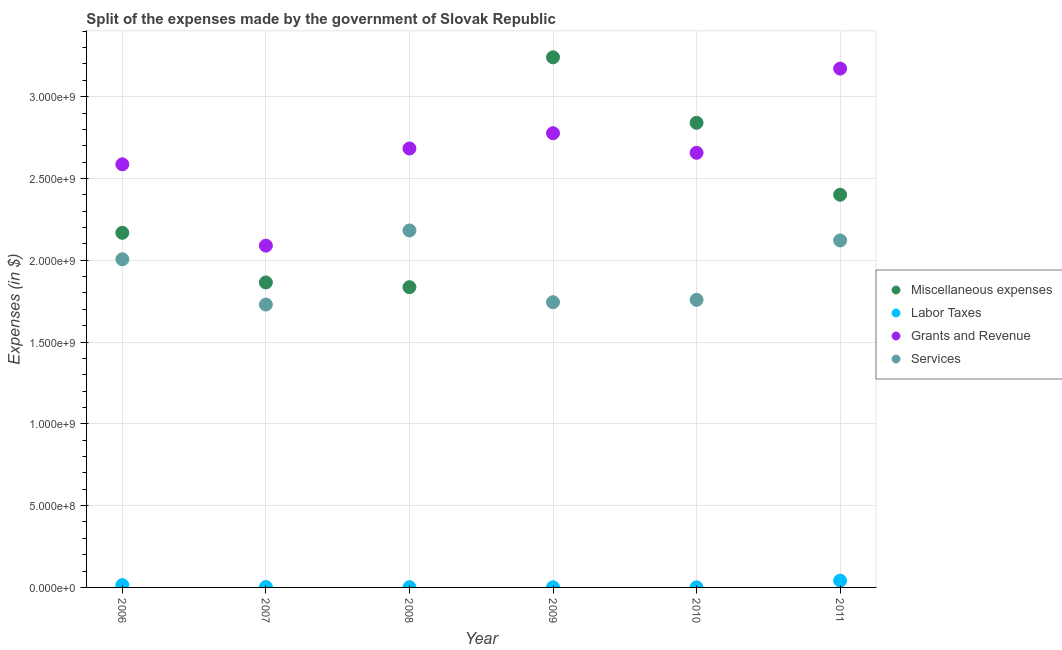Is the number of dotlines equal to the number of legend labels?
Your answer should be compact. Yes. What is the amount spent on labor taxes in 2007?
Keep it short and to the point. 2.58e+06. Across all years, what is the maximum amount spent on services?
Ensure brevity in your answer.  2.18e+09. Across all years, what is the minimum amount spent on grants and revenue?
Your response must be concise. 2.09e+09. What is the total amount spent on services in the graph?
Your answer should be very brief. 1.15e+1. What is the difference between the amount spent on grants and revenue in 2006 and that in 2007?
Your response must be concise. 4.97e+08. What is the difference between the amount spent on services in 2007 and the amount spent on labor taxes in 2008?
Offer a very short reply. 1.73e+09. What is the average amount spent on grants and revenue per year?
Your answer should be compact. 2.66e+09. In the year 2010, what is the difference between the amount spent on miscellaneous expenses and amount spent on labor taxes?
Your response must be concise. 2.84e+09. What is the ratio of the amount spent on miscellaneous expenses in 2006 to that in 2009?
Keep it short and to the point. 0.67. What is the difference between the highest and the second highest amount spent on grants and revenue?
Offer a very short reply. 3.95e+08. What is the difference between the highest and the lowest amount spent on grants and revenue?
Ensure brevity in your answer.  1.08e+09. In how many years, is the amount spent on grants and revenue greater than the average amount spent on grants and revenue taken over all years?
Your answer should be compact. 3. Is the sum of the amount spent on labor taxes in 2008 and 2009 greater than the maximum amount spent on grants and revenue across all years?
Offer a very short reply. No. Is it the case that in every year, the sum of the amount spent on labor taxes and amount spent on services is greater than the sum of amount spent on grants and revenue and amount spent on miscellaneous expenses?
Give a very brief answer. No. Does the amount spent on grants and revenue monotonically increase over the years?
Give a very brief answer. No. Is the amount spent on labor taxes strictly greater than the amount spent on grants and revenue over the years?
Make the answer very short. No. Is the amount spent on labor taxes strictly less than the amount spent on miscellaneous expenses over the years?
Your answer should be compact. Yes. What is the difference between two consecutive major ticks on the Y-axis?
Ensure brevity in your answer.  5.00e+08. Are the values on the major ticks of Y-axis written in scientific E-notation?
Provide a short and direct response. Yes. Does the graph contain any zero values?
Offer a very short reply. No. Where does the legend appear in the graph?
Ensure brevity in your answer.  Center right. How many legend labels are there?
Your answer should be compact. 4. How are the legend labels stacked?
Offer a terse response. Vertical. What is the title of the graph?
Offer a terse response. Split of the expenses made by the government of Slovak Republic. What is the label or title of the Y-axis?
Offer a terse response. Expenses (in $). What is the Expenses (in $) of Miscellaneous expenses in 2006?
Give a very brief answer. 2.17e+09. What is the Expenses (in $) in Labor Taxes in 2006?
Provide a succinct answer. 1.41e+07. What is the Expenses (in $) of Grants and Revenue in 2006?
Ensure brevity in your answer.  2.59e+09. What is the Expenses (in $) in Services in 2006?
Your response must be concise. 2.01e+09. What is the Expenses (in $) in Miscellaneous expenses in 2007?
Provide a short and direct response. 1.86e+09. What is the Expenses (in $) of Labor Taxes in 2007?
Offer a terse response. 2.58e+06. What is the Expenses (in $) of Grants and Revenue in 2007?
Your response must be concise. 2.09e+09. What is the Expenses (in $) in Services in 2007?
Keep it short and to the point. 1.73e+09. What is the Expenses (in $) of Miscellaneous expenses in 2008?
Your answer should be compact. 1.84e+09. What is the Expenses (in $) of Labor Taxes in 2008?
Offer a very short reply. 1.39e+06. What is the Expenses (in $) of Grants and Revenue in 2008?
Give a very brief answer. 2.68e+09. What is the Expenses (in $) of Services in 2008?
Provide a succinct answer. 2.18e+09. What is the Expenses (in $) of Miscellaneous expenses in 2009?
Your answer should be very brief. 3.24e+09. What is the Expenses (in $) of Labor Taxes in 2009?
Offer a very short reply. 7.25e+05. What is the Expenses (in $) of Grants and Revenue in 2009?
Offer a very short reply. 2.78e+09. What is the Expenses (in $) of Services in 2009?
Keep it short and to the point. 1.74e+09. What is the Expenses (in $) in Miscellaneous expenses in 2010?
Ensure brevity in your answer.  2.84e+09. What is the Expenses (in $) in Labor Taxes in 2010?
Your response must be concise. 3.61e+05. What is the Expenses (in $) of Grants and Revenue in 2010?
Keep it short and to the point. 2.66e+09. What is the Expenses (in $) in Services in 2010?
Offer a very short reply. 1.76e+09. What is the Expenses (in $) in Miscellaneous expenses in 2011?
Offer a very short reply. 2.40e+09. What is the Expenses (in $) of Labor Taxes in 2011?
Offer a very short reply. 4.13e+07. What is the Expenses (in $) in Grants and Revenue in 2011?
Make the answer very short. 3.17e+09. What is the Expenses (in $) of Services in 2011?
Make the answer very short. 2.12e+09. Across all years, what is the maximum Expenses (in $) in Miscellaneous expenses?
Your response must be concise. 3.24e+09. Across all years, what is the maximum Expenses (in $) of Labor Taxes?
Your answer should be very brief. 4.13e+07. Across all years, what is the maximum Expenses (in $) of Grants and Revenue?
Ensure brevity in your answer.  3.17e+09. Across all years, what is the maximum Expenses (in $) of Services?
Your answer should be compact. 2.18e+09. Across all years, what is the minimum Expenses (in $) of Miscellaneous expenses?
Give a very brief answer. 1.84e+09. Across all years, what is the minimum Expenses (in $) of Labor Taxes?
Provide a short and direct response. 3.61e+05. Across all years, what is the minimum Expenses (in $) of Grants and Revenue?
Your answer should be very brief. 2.09e+09. Across all years, what is the minimum Expenses (in $) in Services?
Provide a short and direct response. 1.73e+09. What is the total Expenses (in $) of Miscellaneous expenses in the graph?
Make the answer very short. 1.43e+1. What is the total Expenses (in $) in Labor Taxes in the graph?
Your answer should be compact. 6.05e+07. What is the total Expenses (in $) of Grants and Revenue in the graph?
Keep it short and to the point. 1.60e+1. What is the total Expenses (in $) in Services in the graph?
Give a very brief answer. 1.15e+1. What is the difference between the Expenses (in $) of Miscellaneous expenses in 2006 and that in 2007?
Ensure brevity in your answer.  3.03e+08. What is the difference between the Expenses (in $) in Labor Taxes in 2006 and that in 2007?
Offer a terse response. 1.15e+07. What is the difference between the Expenses (in $) in Grants and Revenue in 2006 and that in 2007?
Ensure brevity in your answer.  4.97e+08. What is the difference between the Expenses (in $) in Services in 2006 and that in 2007?
Your answer should be very brief. 2.77e+08. What is the difference between the Expenses (in $) in Miscellaneous expenses in 2006 and that in 2008?
Provide a short and direct response. 3.32e+08. What is the difference between the Expenses (in $) in Labor Taxes in 2006 and that in 2008?
Your answer should be very brief. 1.27e+07. What is the difference between the Expenses (in $) in Grants and Revenue in 2006 and that in 2008?
Offer a terse response. -9.66e+07. What is the difference between the Expenses (in $) in Services in 2006 and that in 2008?
Make the answer very short. -1.76e+08. What is the difference between the Expenses (in $) of Miscellaneous expenses in 2006 and that in 2009?
Your answer should be compact. -1.07e+09. What is the difference between the Expenses (in $) in Labor Taxes in 2006 and that in 2009?
Provide a succinct answer. 1.34e+07. What is the difference between the Expenses (in $) of Grants and Revenue in 2006 and that in 2009?
Keep it short and to the point. -1.90e+08. What is the difference between the Expenses (in $) of Services in 2006 and that in 2009?
Your answer should be very brief. 2.63e+08. What is the difference between the Expenses (in $) of Miscellaneous expenses in 2006 and that in 2010?
Offer a terse response. -6.73e+08. What is the difference between the Expenses (in $) of Labor Taxes in 2006 and that in 2010?
Keep it short and to the point. 1.37e+07. What is the difference between the Expenses (in $) of Grants and Revenue in 2006 and that in 2010?
Keep it short and to the point. -7.03e+07. What is the difference between the Expenses (in $) of Services in 2006 and that in 2010?
Give a very brief answer. 2.48e+08. What is the difference between the Expenses (in $) in Miscellaneous expenses in 2006 and that in 2011?
Make the answer very short. -2.33e+08. What is the difference between the Expenses (in $) of Labor Taxes in 2006 and that in 2011?
Give a very brief answer. -2.72e+07. What is the difference between the Expenses (in $) in Grants and Revenue in 2006 and that in 2011?
Your answer should be very brief. -5.85e+08. What is the difference between the Expenses (in $) of Services in 2006 and that in 2011?
Offer a terse response. -1.15e+08. What is the difference between the Expenses (in $) in Miscellaneous expenses in 2007 and that in 2008?
Ensure brevity in your answer.  2.90e+07. What is the difference between the Expenses (in $) in Labor Taxes in 2007 and that in 2008?
Offer a very short reply. 1.19e+06. What is the difference between the Expenses (in $) of Grants and Revenue in 2007 and that in 2008?
Offer a terse response. -5.94e+08. What is the difference between the Expenses (in $) in Services in 2007 and that in 2008?
Keep it short and to the point. -4.53e+08. What is the difference between the Expenses (in $) of Miscellaneous expenses in 2007 and that in 2009?
Your response must be concise. -1.38e+09. What is the difference between the Expenses (in $) in Labor Taxes in 2007 and that in 2009?
Give a very brief answer. 1.86e+06. What is the difference between the Expenses (in $) of Grants and Revenue in 2007 and that in 2009?
Offer a terse response. -6.87e+08. What is the difference between the Expenses (in $) of Services in 2007 and that in 2009?
Provide a short and direct response. -1.42e+07. What is the difference between the Expenses (in $) of Miscellaneous expenses in 2007 and that in 2010?
Give a very brief answer. -9.76e+08. What is the difference between the Expenses (in $) of Labor Taxes in 2007 and that in 2010?
Provide a short and direct response. 2.22e+06. What is the difference between the Expenses (in $) of Grants and Revenue in 2007 and that in 2010?
Offer a very short reply. -5.68e+08. What is the difference between the Expenses (in $) in Services in 2007 and that in 2010?
Provide a short and direct response. -2.88e+07. What is the difference between the Expenses (in $) of Miscellaneous expenses in 2007 and that in 2011?
Ensure brevity in your answer.  -5.36e+08. What is the difference between the Expenses (in $) in Labor Taxes in 2007 and that in 2011?
Provide a short and direct response. -3.87e+07. What is the difference between the Expenses (in $) of Grants and Revenue in 2007 and that in 2011?
Provide a succinct answer. -1.08e+09. What is the difference between the Expenses (in $) in Services in 2007 and that in 2011?
Your response must be concise. -3.92e+08. What is the difference between the Expenses (in $) in Miscellaneous expenses in 2008 and that in 2009?
Your answer should be compact. -1.41e+09. What is the difference between the Expenses (in $) in Labor Taxes in 2008 and that in 2009?
Ensure brevity in your answer.  6.67e+05. What is the difference between the Expenses (in $) in Grants and Revenue in 2008 and that in 2009?
Your response must be concise. -9.34e+07. What is the difference between the Expenses (in $) in Services in 2008 and that in 2009?
Provide a succinct answer. 4.39e+08. What is the difference between the Expenses (in $) in Miscellaneous expenses in 2008 and that in 2010?
Provide a short and direct response. -1.00e+09. What is the difference between the Expenses (in $) in Labor Taxes in 2008 and that in 2010?
Provide a short and direct response. 1.03e+06. What is the difference between the Expenses (in $) in Grants and Revenue in 2008 and that in 2010?
Ensure brevity in your answer.  2.63e+07. What is the difference between the Expenses (in $) of Services in 2008 and that in 2010?
Your answer should be compact. 4.24e+08. What is the difference between the Expenses (in $) of Miscellaneous expenses in 2008 and that in 2011?
Your response must be concise. -5.65e+08. What is the difference between the Expenses (in $) in Labor Taxes in 2008 and that in 2011?
Your answer should be compact. -3.99e+07. What is the difference between the Expenses (in $) of Grants and Revenue in 2008 and that in 2011?
Make the answer very short. -4.88e+08. What is the difference between the Expenses (in $) of Services in 2008 and that in 2011?
Ensure brevity in your answer.  6.11e+07. What is the difference between the Expenses (in $) of Miscellaneous expenses in 2009 and that in 2010?
Give a very brief answer. 4.00e+08. What is the difference between the Expenses (in $) of Labor Taxes in 2009 and that in 2010?
Your answer should be very brief. 3.64e+05. What is the difference between the Expenses (in $) of Grants and Revenue in 2009 and that in 2010?
Ensure brevity in your answer.  1.20e+08. What is the difference between the Expenses (in $) of Services in 2009 and that in 2010?
Provide a short and direct response. -1.45e+07. What is the difference between the Expenses (in $) of Miscellaneous expenses in 2009 and that in 2011?
Your response must be concise. 8.40e+08. What is the difference between the Expenses (in $) of Labor Taxes in 2009 and that in 2011?
Keep it short and to the point. -4.06e+07. What is the difference between the Expenses (in $) in Grants and Revenue in 2009 and that in 2011?
Offer a terse response. -3.95e+08. What is the difference between the Expenses (in $) in Services in 2009 and that in 2011?
Keep it short and to the point. -3.78e+08. What is the difference between the Expenses (in $) in Miscellaneous expenses in 2010 and that in 2011?
Make the answer very short. 4.40e+08. What is the difference between the Expenses (in $) in Labor Taxes in 2010 and that in 2011?
Provide a succinct answer. -4.10e+07. What is the difference between the Expenses (in $) in Grants and Revenue in 2010 and that in 2011?
Make the answer very short. -5.15e+08. What is the difference between the Expenses (in $) in Services in 2010 and that in 2011?
Offer a terse response. -3.63e+08. What is the difference between the Expenses (in $) in Miscellaneous expenses in 2006 and the Expenses (in $) in Labor Taxes in 2007?
Keep it short and to the point. 2.17e+09. What is the difference between the Expenses (in $) in Miscellaneous expenses in 2006 and the Expenses (in $) in Grants and Revenue in 2007?
Give a very brief answer. 7.84e+07. What is the difference between the Expenses (in $) of Miscellaneous expenses in 2006 and the Expenses (in $) of Services in 2007?
Provide a succinct answer. 4.39e+08. What is the difference between the Expenses (in $) of Labor Taxes in 2006 and the Expenses (in $) of Grants and Revenue in 2007?
Your response must be concise. -2.08e+09. What is the difference between the Expenses (in $) of Labor Taxes in 2006 and the Expenses (in $) of Services in 2007?
Give a very brief answer. -1.72e+09. What is the difference between the Expenses (in $) in Grants and Revenue in 2006 and the Expenses (in $) in Services in 2007?
Make the answer very short. 8.57e+08. What is the difference between the Expenses (in $) in Miscellaneous expenses in 2006 and the Expenses (in $) in Labor Taxes in 2008?
Offer a very short reply. 2.17e+09. What is the difference between the Expenses (in $) in Miscellaneous expenses in 2006 and the Expenses (in $) in Grants and Revenue in 2008?
Offer a very short reply. -5.15e+08. What is the difference between the Expenses (in $) in Miscellaneous expenses in 2006 and the Expenses (in $) in Services in 2008?
Your answer should be very brief. -1.45e+07. What is the difference between the Expenses (in $) in Labor Taxes in 2006 and the Expenses (in $) in Grants and Revenue in 2008?
Make the answer very short. -2.67e+09. What is the difference between the Expenses (in $) in Labor Taxes in 2006 and the Expenses (in $) in Services in 2008?
Ensure brevity in your answer.  -2.17e+09. What is the difference between the Expenses (in $) of Grants and Revenue in 2006 and the Expenses (in $) of Services in 2008?
Your response must be concise. 4.04e+08. What is the difference between the Expenses (in $) of Miscellaneous expenses in 2006 and the Expenses (in $) of Labor Taxes in 2009?
Provide a short and direct response. 2.17e+09. What is the difference between the Expenses (in $) of Miscellaneous expenses in 2006 and the Expenses (in $) of Grants and Revenue in 2009?
Make the answer very short. -6.09e+08. What is the difference between the Expenses (in $) of Miscellaneous expenses in 2006 and the Expenses (in $) of Services in 2009?
Your answer should be compact. 4.24e+08. What is the difference between the Expenses (in $) in Labor Taxes in 2006 and the Expenses (in $) in Grants and Revenue in 2009?
Your answer should be very brief. -2.76e+09. What is the difference between the Expenses (in $) in Labor Taxes in 2006 and the Expenses (in $) in Services in 2009?
Give a very brief answer. -1.73e+09. What is the difference between the Expenses (in $) of Grants and Revenue in 2006 and the Expenses (in $) of Services in 2009?
Your answer should be very brief. 8.43e+08. What is the difference between the Expenses (in $) of Miscellaneous expenses in 2006 and the Expenses (in $) of Labor Taxes in 2010?
Provide a short and direct response. 2.17e+09. What is the difference between the Expenses (in $) in Miscellaneous expenses in 2006 and the Expenses (in $) in Grants and Revenue in 2010?
Make the answer very short. -4.89e+08. What is the difference between the Expenses (in $) in Miscellaneous expenses in 2006 and the Expenses (in $) in Services in 2010?
Offer a very short reply. 4.10e+08. What is the difference between the Expenses (in $) of Labor Taxes in 2006 and the Expenses (in $) of Grants and Revenue in 2010?
Offer a very short reply. -2.64e+09. What is the difference between the Expenses (in $) in Labor Taxes in 2006 and the Expenses (in $) in Services in 2010?
Your response must be concise. -1.74e+09. What is the difference between the Expenses (in $) in Grants and Revenue in 2006 and the Expenses (in $) in Services in 2010?
Offer a terse response. 8.29e+08. What is the difference between the Expenses (in $) of Miscellaneous expenses in 2006 and the Expenses (in $) of Labor Taxes in 2011?
Offer a terse response. 2.13e+09. What is the difference between the Expenses (in $) of Miscellaneous expenses in 2006 and the Expenses (in $) of Grants and Revenue in 2011?
Your response must be concise. -1.00e+09. What is the difference between the Expenses (in $) in Miscellaneous expenses in 2006 and the Expenses (in $) in Services in 2011?
Make the answer very short. 4.66e+07. What is the difference between the Expenses (in $) in Labor Taxes in 2006 and the Expenses (in $) in Grants and Revenue in 2011?
Your answer should be compact. -3.16e+09. What is the difference between the Expenses (in $) of Labor Taxes in 2006 and the Expenses (in $) of Services in 2011?
Provide a succinct answer. -2.11e+09. What is the difference between the Expenses (in $) of Grants and Revenue in 2006 and the Expenses (in $) of Services in 2011?
Your response must be concise. 4.65e+08. What is the difference between the Expenses (in $) in Miscellaneous expenses in 2007 and the Expenses (in $) in Labor Taxes in 2008?
Your response must be concise. 1.86e+09. What is the difference between the Expenses (in $) in Miscellaneous expenses in 2007 and the Expenses (in $) in Grants and Revenue in 2008?
Give a very brief answer. -8.19e+08. What is the difference between the Expenses (in $) in Miscellaneous expenses in 2007 and the Expenses (in $) in Services in 2008?
Offer a terse response. -3.18e+08. What is the difference between the Expenses (in $) of Labor Taxes in 2007 and the Expenses (in $) of Grants and Revenue in 2008?
Offer a very short reply. -2.68e+09. What is the difference between the Expenses (in $) in Labor Taxes in 2007 and the Expenses (in $) in Services in 2008?
Your answer should be very brief. -2.18e+09. What is the difference between the Expenses (in $) in Grants and Revenue in 2007 and the Expenses (in $) in Services in 2008?
Your answer should be very brief. -9.29e+07. What is the difference between the Expenses (in $) in Miscellaneous expenses in 2007 and the Expenses (in $) in Labor Taxes in 2009?
Your response must be concise. 1.86e+09. What is the difference between the Expenses (in $) of Miscellaneous expenses in 2007 and the Expenses (in $) of Grants and Revenue in 2009?
Your answer should be compact. -9.12e+08. What is the difference between the Expenses (in $) in Miscellaneous expenses in 2007 and the Expenses (in $) in Services in 2009?
Your response must be concise. 1.21e+08. What is the difference between the Expenses (in $) in Labor Taxes in 2007 and the Expenses (in $) in Grants and Revenue in 2009?
Keep it short and to the point. -2.77e+09. What is the difference between the Expenses (in $) of Labor Taxes in 2007 and the Expenses (in $) of Services in 2009?
Make the answer very short. -1.74e+09. What is the difference between the Expenses (in $) in Grants and Revenue in 2007 and the Expenses (in $) in Services in 2009?
Make the answer very short. 3.46e+08. What is the difference between the Expenses (in $) of Miscellaneous expenses in 2007 and the Expenses (in $) of Labor Taxes in 2010?
Your answer should be compact. 1.86e+09. What is the difference between the Expenses (in $) in Miscellaneous expenses in 2007 and the Expenses (in $) in Grants and Revenue in 2010?
Your response must be concise. -7.92e+08. What is the difference between the Expenses (in $) in Miscellaneous expenses in 2007 and the Expenses (in $) in Services in 2010?
Give a very brief answer. 1.06e+08. What is the difference between the Expenses (in $) in Labor Taxes in 2007 and the Expenses (in $) in Grants and Revenue in 2010?
Offer a very short reply. -2.65e+09. What is the difference between the Expenses (in $) of Labor Taxes in 2007 and the Expenses (in $) of Services in 2010?
Offer a terse response. -1.76e+09. What is the difference between the Expenses (in $) of Grants and Revenue in 2007 and the Expenses (in $) of Services in 2010?
Offer a terse response. 3.31e+08. What is the difference between the Expenses (in $) in Miscellaneous expenses in 2007 and the Expenses (in $) in Labor Taxes in 2011?
Provide a succinct answer. 1.82e+09. What is the difference between the Expenses (in $) in Miscellaneous expenses in 2007 and the Expenses (in $) in Grants and Revenue in 2011?
Your answer should be compact. -1.31e+09. What is the difference between the Expenses (in $) of Miscellaneous expenses in 2007 and the Expenses (in $) of Services in 2011?
Your answer should be very brief. -2.57e+08. What is the difference between the Expenses (in $) of Labor Taxes in 2007 and the Expenses (in $) of Grants and Revenue in 2011?
Keep it short and to the point. -3.17e+09. What is the difference between the Expenses (in $) of Labor Taxes in 2007 and the Expenses (in $) of Services in 2011?
Offer a very short reply. -2.12e+09. What is the difference between the Expenses (in $) in Grants and Revenue in 2007 and the Expenses (in $) in Services in 2011?
Ensure brevity in your answer.  -3.18e+07. What is the difference between the Expenses (in $) in Miscellaneous expenses in 2008 and the Expenses (in $) in Labor Taxes in 2009?
Your response must be concise. 1.83e+09. What is the difference between the Expenses (in $) of Miscellaneous expenses in 2008 and the Expenses (in $) of Grants and Revenue in 2009?
Ensure brevity in your answer.  -9.41e+08. What is the difference between the Expenses (in $) in Miscellaneous expenses in 2008 and the Expenses (in $) in Services in 2009?
Your response must be concise. 9.20e+07. What is the difference between the Expenses (in $) in Labor Taxes in 2008 and the Expenses (in $) in Grants and Revenue in 2009?
Offer a very short reply. -2.78e+09. What is the difference between the Expenses (in $) of Labor Taxes in 2008 and the Expenses (in $) of Services in 2009?
Provide a short and direct response. -1.74e+09. What is the difference between the Expenses (in $) of Grants and Revenue in 2008 and the Expenses (in $) of Services in 2009?
Ensure brevity in your answer.  9.40e+08. What is the difference between the Expenses (in $) of Miscellaneous expenses in 2008 and the Expenses (in $) of Labor Taxes in 2010?
Keep it short and to the point. 1.84e+09. What is the difference between the Expenses (in $) in Miscellaneous expenses in 2008 and the Expenses (in $) in Grants and Revenue in 2010?
Ensure brevity in your answer.  -8.21e+08. What is the difference between the Expenses (in $) of Miscellaneous expenses in 2008 and the Expenses (in $) of Services in 2010?
Your answer should be very brief. 7.75e+07. What is the difference between the Expenses (in $) of Labor Taxes in 2008 and the Expenses (in $) of Grants and Revenue in 2010?
Your response must be concise. -2.66e+09. What is the difference between the Expenses (in $) of Labor Taxes in 2008 and the Expenses (in $) of Services in 2010?
Provide a succinct answer. -1.76e+09. What is the difference between the Expenses (in $) of Grants and Revenue in 2008 and the Expenses (in $) of Services in 2010?
Your response must be concise. 9.25e+08. What is the difference between the Expenses (in $) in Miscellaneous expenses in 2008 and the Expenses (in $) in Labor Taxes in 2011?
Your answer should be compact. 1.79e+09. What is the difference between the Expenses (in $) of Miscellaneous expenses in 2008 and the Expenses (in $) of Grants and Revenue in 2011?
Give a very brief answer. -1.34e+09. What is the difference between the Expenses (in $) in Miscellaneous expenses in 2008 and the Expenses (in $) in Services in 2011?
Your response must be concise. -2.86e+08. What is the difference between the Expenses (in $) in Labor Taxes in 2008 and the Expenses (in $) in Grants and Revenue in 2011?
Make the answer very short. -3.17e+09. What is the difference between the Expenses (in $) of Labor Taxes in 2008 and the Expenses (in $) of Services in 2011?
Your answer should be compact. -2.12e+09. What is the difference between the Expenses (in $) in Grants and Revenue in 2008 and the Expenses (in $) in Services in 2011?
Provide a succinct answer. 5.62e+08. What is the difference between the Expenses (in $) in Miscellaneous expenses in 2009 and the Expenses (in $) in Labor Taxes in 2010?
Your answer should be very brief. 3.24e+09. What is the difference between the Expenses (in $) of Miscellaneous expenses in 2009 and the Expenses (in $) of Grants and Revenue in 2010?
Ensure brevity in your answer.  5.84e+08. What is the difference between the Expenses (in $) in Miscellaneous expenses in 2009 and the Expenses (in $) in Services in 2010?
Keep it short and to the point. 1.48e+09. What is the difference between the Expenses (in $) of Labor Taxes in 2009 and the Expenses (in $) of Grants and Revenue in 2010?
Your answer should be compact. -2.66e+09. What is the difference between the Expenses (in $) in Labor Taxes in 2009 and the Expenses (in $) in Services in 2010?
Keep it short and to the point. -1.76e+09. What is the difference between the Expenses (in $) in Grants and Revenue in 2009 and the Expenses (in $) in Services in 2010?
Make the answer very short. 1.02e+09. What is the difference between the Expenses (in $) in Miscellaneous expenses in 2009 and the Expenses (in $) in Labor Taxes in 2011?
Provide a short and direct response. 3.20e+09. What is the difference between the Expenses (in $) of Miscellaneous expenses in 2009 and the Expenses (in $) of Grants and Revenue in 2011?
Keep it short and to the point. 6.89e+07. What is the difference between the Expenses (in $) in Miscellaneous expenses in 2009 and the Expenses (in $) in Services in 2011?
Keep it short and to the point. 1.12e+09. What is the difference between the Expenses (in $) of Labor Taxes in 2009 and the Expenses (in $) of Grants and Revenue in 2011?
Offer a very short reply. -3.17e+09. What is the difference between the Expenses (in $) in Labor Taxes in 2009 and the Expenses (in $) in Services in 2011?
Give a very brief answer. -2.12e+09. What is the difference between the Expenses (in $) in Grants and Revenue in 2009 and the Expenses (in $) in Services in 2011?
Provide a succinct answer. 6.55e+08. What is the difference between the Expenses (in $) in Miscellaneous expenses in 2010 and the Expenses (in $) in Labor Taxes in 2011?
Make the answer very short. 2.80e+09. What is the difference between the Expenses (in $) of Miscellaneous expenses in 2010 and the Expenses (in $) of Grants and Revenue in 2011?
Your response must be concise. -3.31e+08. What is the difference between the Expenses (in $) in Miscellaneous expenses in 2010 and the Expenses (in $) in Services in 2011?
Keep it short and to the point. 7.19e+08. What is the difference between the Expenses (in $) of Labor Taxes in 2010 and the Expenses (in $) of Grants and Revenue in 2011?
Offer a terse response. -3.17e+09. What is the difference between the Expenses (in $) of Labor Taxes in 2010 and the Expenses (in $) of Services in 2011?
Your response must be concise. -2.12e+09. What is the difference between the Expenses (in $) in Grants and Revenue in 2010 and the Expenses (in $) in Services in 2011?
Offer a terse response. 5.36e+08. What is the average Expenses (in $) in Miscellaneous expenses per year?
Provide a succinct answer. 2.39e+09. What is the average Expenses (in $) in Labor Taxes per year?
Offer a terse response. 1.01e+07. What is the average Expenses (in $) in Grants and Revenue per year?
Give a very brief answer. 2.66e+09. What is the average Expenses (in $) in Services per year?
Offer a very short reply. 1.92e+09. In the year 2006, what is the difference between the Expenses (in $) of Miscellaneous expenses and Expenses (in $) of Labor Taxes?
Make the answer very short. 2.15e+09. In the year 2006, what is the difference between the Expenses (in $) of Miscellaneous expenses and Expenses (in $) of Grants and Revenue?
Your answer should be very brief. -4.19e+08. In the year 2006, what is the difference between the Expenses (in $) of Miscellaneous expenses and Expenses (in $) of Services?
Provide a short and direct response. 1.62e+08. In the year 2006, what is the difference between the Expenses (in $) in Labor Taxes and Expenses (in $) in Grants and Revenue?
Offer a very short reply. -2.57e+09. In the year 2006, what is the difference between the Expenses (in $) in Labor Taxes and Expenses (in $) in Services?
Keep it short and to the point. -1.99e+09. In the year 2006, what is the difference between the Expenses (in $) in Grants and Revenue and Expenses (in $) in Services?
Ensure brevity in your answer.  5.81e+08. In the year 2007, what is the difference between the Expenses (in $) of Miscellaneous expenses and Expenses (in $) of Labor Taxes?
Your answer should be compact. 1.86e+09. In the year 2007, what is the difference between the Expenses (in $) of Miscellaneous expenses and Expenses (in $) of Grants and Revenue?
Give a very brief answer. -2.25e+08. In the year 2007, what is the difference between the Expenses (in $) of Miscellaneous expenses and Expenses (in $) of Services?
Make the answer very short. 1.35e+08. In the year 2007, what is the difference between the Expenses (in $) in Labor Taxes and Expenses (in $) in Grants and Revenue?
Your answer should be compact. -2.09e+09. In the year 2007, what is the difference between the Expenses (in $) in Labor Taxes and Expenses (in $) in Services?
Provide a short and direct response. -1.73e+09. In the year 2007, what is the difference between the Expenses (in $) of Grants and Revenue and Expenses (in $) of Services?
Make the answer very short. 3.60e+08. In the year 2008, what is the difference between the Expenses (in $) in Miscellaneous expenses and Expenses (in $) in Labor Taxes?
Offer a very short reply. 1.83e+09. In the year 2008, what is the difference between the Expenses (in $) of Miscellaneous expenses and Expenses (in $) of Grants and Revenue?
Your answer should be very brief. -8.48e+08. In the year 2008, what is the difference between the Expenses (in $) of Miscellaneous expenses and Expenses (in $) of Services?
Keep it short and to the point. -3.47e+08. In the year 2008, what is the difference between the Expenses (in $) in Labor Taxes and Expenses (in $) in Grants and Revenue?
Ensure brevity in your answer.  -2.68e+09. In the year 2008, what is the difference between the Expenses (in $) in Labor Taxes and Expenses (in $) in Services?
Keep it short and to the point. -2.18e+09. In the year 2008, what is the difference between the Expenses (in $) in Grants and Revenue and Expenses (in $) in Services?
Your answer should be very brief. 5.01e+08. In the year 2009, what is the difference between the Expenses (in $) in Miscellaneous expenses and Expenses (in $) in Labor Taxes?
Keep it short and to the point. 3.24e+09. In the year 2009, what is the difference between the Expenses (in $) in Miscellaneous expenses and Expenses (in $) in Grants and Revenue?
Offer a terse response. 4.64e+08. In the year 2009, what is the difference between the Expenses (in $) of Miscellaneous expenses and Expenses (in $) of Services?
Your answer should be compact. 1.50e+09. In the year 2009, what is the difference between the Expenses (in $) in Labor Taxes and Expenses (in $) in Grants and Revenue?
Offer a very short reply. -2.78e+09. In the year 2009, what is the difference between the Expenses (in $) in Labor Taxes and Expenses (in $) in Services?
Ensure brevity in your answer.  -1.74e+09. In the year 2009, what is the difference between the Expenses (in $) of Grants and Revenue and Expenses (in $) of Services?
Provide a short and direct response. 1.03e+09. In the year 2010, what is the difference between the Expenses (in $) of Miscellaneous expenses and Expenses (in $) of Labor Taxes?
Your answer should be very brief. 2.84e+09. In the year 2010, what is the difference between the Expenses (in $) of Miscellaneous expenses and Expenses (in $) of Grants and Revenue?
Keep it short and to the point. 1.83e+08. In the year 2010, what is the difference between the Expenses (in $) in Miscellaneous expenses and Expenses (in $) in Services?
Make the answer very short. 1.08e+09. In the year 2010, what is the difference between the Expenses (in $) in Labor Taxes and Expenses (in $) in Grants and Revenue?
Offer a very short reply. -2.66e+09. In the year 2010, what is the difference between the Expenses (in $) of Labor Taxes and Expenses (in $) of Services?
Give a very brief answer. -1.76e+09. In the year 2010, what is the difference between the Expenses (in $) of Grants and Revenue and Expenses (in $) of Services?
Make the answer very short. 8.99e+08. In the year 2011, what is the difference between the Expenses (in $) in Miscellaneous expenses and Expenses (in $) in Labor Taxes?
Your response must be concise. 2.36e+09. In the year 2011, what is the difference between the Expenses (in $) in Miscellaneous expenses and Expenses (in $) in Grants and Revenue?
Offer a very short reply. -7.71e+08. In the year 2011, what is the difference between the Expenses (in $) of Miscellaneous expenses and Expenses (in $) of Services?
Your answer should be very brief. 2.79e+08. In the year 2011, what is the difference between the Expenses (in $) in Labor Taxes and Expenses (in $) in Grants and Revenue?
Provide a short and direct response. -3.13e+09. In the year 2011, what is the difference between the Expenses (in $) in Labor Taxes and Expenses (in $) in Services?
Your response must be concise. -2.08e+09. In the year 2011, what is the difference between the Expenses (in $) of Grants and Revenue and Expenses (in $) of Services?
Give a very brief answer. 1.05e+09. What is the ratio of the Expenses (in $) of Miscellaneous expenses in 2006 to that in 2007?
Keep it short and to the point. 1.16. What is the ratio of the Expenses (in $) of Labor Taxes in 2006 to that in 2007?
Offer a very short reply. 5.46. What is the ratio of the Expenses (in $) of Grants and Revenue in 2006 to that in 2007?
Your response must be concise. 1.24. What is the ratio of the Expenses (in $) in Services in 2006 to that in 2007?
Keep it short and to the point. 1.16. What is the ratio of the Expenses (in $) in Miscellaneous expenses in 2006 to that in 2008?
Ensure brevity in your answer.  1.18. What is the ratio of the Expenses (in $) in Labor Taxes in 2006 to that in 2008?
Ensure brevity in your answer.  10.14. What is the ratio of the Expenses (in $) of Grants and Revenue in 2006 to that in 2008?
Your answer should be compact. 0.96. What is the ratio of the Expenses (in $) in Services in 2006 to that in 2008?
Make the answer very short. 0.92. What is the ratio of the Expenses (in $) of Miscellaneous expenses in 2006 to that in 2009?
Your answer should be very brief. 0.67. What is the ratio of the Expenses (in $) of Labor Taxes in 2006 to that in 2009?
Make the answer very short. 19.46. What is the ratio of the Expenses (in $) in Grants and Revenue in 2006 to that in 2009?
Offer a very short reply. 0.93. What is the ratio of the Expenses (in $) of Services in 2006 to that in 2009?
Make the answer very short. 1.15. What is the ratio of the Expenses (in $) of Miscellaneous expenses in 2006 to that in 2010?
Keep it short and to the point. 0.76. What is the ratio of the Expenses (in $) of Labor Taxes in 2006 to that in 2010?
Offer a very short reply. 39.06. What is the ratio of the Expenses (in $) in Grants and Revenue in 2006 to that in 2010?
Your response must be concise. 0.97. What is the ratio of the Expenses (in $) in Services in 2006 to that in 2010?
Your answer should be compact. 1.14. What is the ratio of the Expenses (in $) in Miscellaneous expenses in 2006 to that in 2011?
Offer a very short reply. 0.9. What is the ratio of the Expenses (in $) in Labor Taxes in 2006 to that in 2011?
Provide a short and direct response. 0.34. What is the ratio of the Expenses (in $) in Grants and Revenue in 2006 to that in 2011?
Provide a short and direct response. 0.82. What is the ratio of the Expenses (in $) of Services in 2006 to that in 2011?
Provide a short and direct response. 0.95. What is the ratio of the Expenses (in $) of Miscellaneous expenses in 2007 to that in 2008?
Offer a very short reply. 1.02. What is the ratio of the Expenses (in $) of Labor Taxes in 2007 to that in 2008?
Ensure brevity in your answer.  1.86. What is the ratio of the Expenses (in $) of Grants and Revenue in 2007 to that in 2008?
Provide a succinct answer. 0.78. What is the ratio of the Expenses (in $) in Services in 2007 to that in 2008?
Give a very brief answer. 0.79. What is the ratio of the Expenses (in $) in Miscellaneous expenses in 2007 to that in 2009?
Keep it short and to the point. 0.58. What is the ratio of the Expenses (in $) of Labor Taxes in 2007 to that in 2009?
Keep it short and to the point. 3.56. What is the ratio of the Expenses (in $) in Grants and Revenue in 2007 to that in 2009?
Keep it short and to the point. 0.75. What is the ratio of the Expenses (in $) in Miscellaneous expenses in 2007 to that in 2010?
Your answer should be very brief. 0.66. What is the ratio of the Expenses (in $) in Labor Taxes in 2007 to that in 2010?
Offer a very short reply. 7.15. What is the ratio of the Expenses (in $) of Grants and Revenue in 2007 to that in 2010?
Keep it short and to the point. 0.79. What is the ratio of the Expenses (in $) of Services in 2007 to that in 2010?
Make the answer very short. 0.98. What is the ratio of the Expenses (in $) of Miscellaneous expenses in 2007 to that in 2011?
Your response must be concise. 0.78. What is the ratio of the Expenses (in $) in Labor Taxes in 2007 to that in 2011?
Provide a succinct answer. 0.06. What is the ratio of the Expenses (in $) of Grants and Revenue in 2007 to that in 2011?
Keep it short and to the point. 0.66. What is the ratio of the Expenses (in $) in Services in 2007 to that in 2011?
Your response must be concise. 0.82. What is the ratio of the Expenses (in $) in Miscellaneous expenses in 2008 to that in 2009?
Your answer should be very brief. 0.57. What is the ratio of the Expenses (in $) of Labor Taxes in 2008 to that in 2009?
Your answer should be compact. 1.92. What is the ratio of the Expenses (in $) of Grants and Revenue in 2008 to that in 2009?
Your answer should be compact. 0.97. What is the ratio of the Expenses (in $) of Services in 2008 to that in 2009?
Your answer should be compact. 1.25. What is the ratio of the Expenses (in $) of Miscellaneous expenses in 2008 to that in 2010?
Offer a terse response. 0.65. What is the ratio of the Expenses (in $) of Labor Taxes in 2008 to that in 2010?
Provide a succinct answer. 3.85. What is the ratio of the Expenses (in $) in Grants and Revenue in 2008 to that in 2010?
Your response must be concise. 1.01. What is the ratio of the Expenses (in $) of Services in 2008 to that in 2010?
Give a very brief answer. 1.24. What is the ratio of the Expenses (in $) of Miscellaneous expenses in 2008 to that in 2011?
Your answer should be very brief. 0.76. What is the ratio of the Expenses (in $) in Labor Taxes in 2008 to that in 2011?
Keep it short and to the point. 0.03. What is the ratio of the Expenses (in $) of Grants and Revenue in 2008 to that in 2011?
Provide a succinct answer. 0.85. What is the ratio of the Expenses (in $) of Services in 2008 to that in 2011?
Offer a very short reply. 1.03. What is the ratio of the Expenses (in $) of Miscellaneous expenses in 2009 to that in 2010?
Your answer should be compact. 1.14. What is the ratio of the Expenses (in $) of Labor Taxes in 2009 to that in 2010?
Ensure brevity in your answer.  2.01. What is the ratio of the Expenses (in $) of Grants and Revenue in 2009 to that in 2010?
Your answer should be compact. 1.05. What is the ratio of the Expenses (in $) of Services in 2009 to that in 2010?
Keep it short and to the point. 0.99. What is the ratio of the Expenses (in $) of Miscellaneous expenses in 2009 to that in 2011?
Offer a terse response. 1.35. What is the ratio of the Expenses (in $) in Labor Taxes in 2009 to that in 2011?
Keep it short and to the point. 0.02. What is the ratio of the Expenses (in $) in Grants and Revenue in 2009 to that in 2011?
Offer a very short reply. 0.88. What is the ratio of the Expenses (in $) of Services in 2009 to that in 2011?
Your answer should be very brief. 0.82. What is the ratio of the Expenses (in $) of Miscellaneous expenses in 2010 to that in 2011?
Offer a terse response. 1.18. What is the ratio of the Expenses (in $) of Labor Taxes in 2010 to that in 2011?
Provide a succinct answer. 0.01. What is the ratio of the Expenses (in $) in Grants and Revenue in 2010 to that in 2011?
Ensure brevity in your answer.  0.84. What is the ratio of the Expenses (in $) in Services in 2010 to that in 2011?
Your response must be concise. 0.83. What is the difference between the highest and the second highest Expenses (in $) in Miscellaneous expenses?
Your answer should be compact. 4.00e+08. What is the difference between the highest and the second highest Expenses (in $) of Labor Taxes?
Ensure brevity in your answer.  2.72e+07. What is the difference between the highest and the second highest Expenses (in $) in Grants and Revenue?
Offer a very short reply. 3.95e+08. What is the difference between the highest and the second highest Expenses (in $) of Services?
Give a very brief answer. 6.11e+07. What is the difference between the highest and the lowest Expenses (in $) of Miscellaneous expenses?
Make the answer very short. 1.41e+09. What is the difference between the highest and the lowest Expenses (in $) in Labor Taxes?
Keep it short and to the point. 4.10e+07. What is the difference between the highest and the lowest Expenses (in $) of Grants and Revenue?
Provide a short and direct response. 1.08e+09. What is the difference between the highest and the lowest Expenses (in $) in Services?
Make the answer very short. 4.53e+08. 